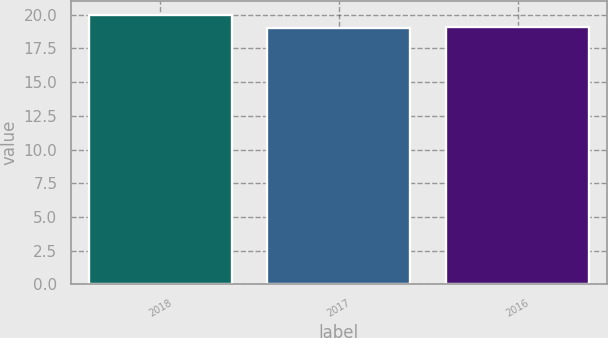<chart> <loc_0><loc_0><loc_500><loc_500><bar_chart><fcel>2018<fcel>2017<fcel>2016<nl><fcel>20<fcel>19<fcel>19.1<nl></chart> 